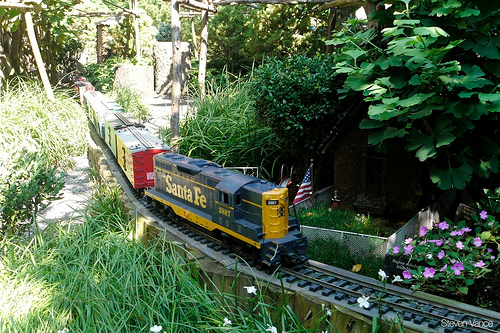Please provide the bounding box coordinate of the region this sentence describes: a small american flag. The small American flag is located within the bounding box coordinates [0.57, 0.5, 0.65, 0.6]. 